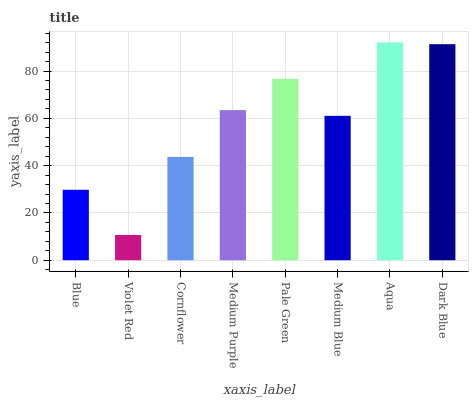Is Cornflower the minimum?
Answer yes or no. No. Is Cornflower the maximum?
Answer yes or no. No. Is Cornflower greater than Violet Red?
Answer yes or no. Yes. Is Violet Red less than Cornflower?
Answer yes or no. Yes. Is Violet Red greater than Cornflower?
Answer yes or no. No. Is Cornflower less than Violet Red?
Answer yes or no. No. Is Medium Purple the high median?
Answer yes or no. Yes. Is Medium Blue the low median?
Answer yes or no. Yes. Is Blue the high median?
Answer yes or no. No. Is Pale Green the low median?
Answer yes or no. No. 